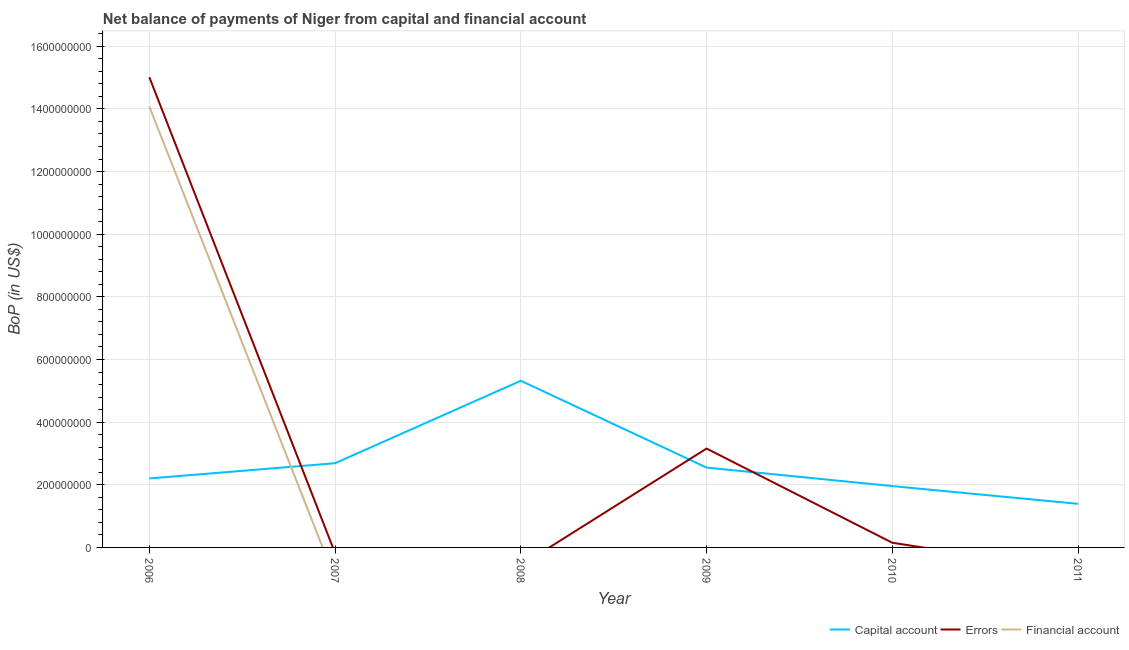How many different coloured lines are there?
Your answer should be very brief. 3. Does the line corresponding to amount of net capital account intersect with the line corresponding to amount of financial account?
Provide a short and direct response. Yes. Is the number of lines equal to the number of legend labels?
Provide a succinct answer. No. What is the amount of errors in 2006?
Your answer should be compact. 1.50e+09. Across all years, what is the maximum amount of errors?
Offer a very short reply. 1.50e+09. What is the total amount of errors in the graph?
Ensure brevity in your answer.  1.83e+09. What is the difference between the amount of net capital account in 2008 and that in 2011?
Give a very brief answer. 3.93e+08. What is the difference between the amount of errors in 2006 and the amount of financial account in 2009?
Keep it short and to the point. 1.50e+09. What is the average amount of financial account per year?
Give a very brief answer. 2.35e+08. In the year 2010, what is the difference between the amount of net capital account and amount of errors?
Keep it short and to the point. 1.81e+08. What is the ratio of the amount of errors in 2006 to that in 2009?
Keep it short and to the point. 4.76. What is the difference between the highest and the second highest amount of errors?
Make the answer very short. 1.19e+09. What is the difference between the highest and the lowest amount of net capital account?
Provide a short and direct response. 3.93e+08. In how many years, is the amount of financial account greater than the average amount of financial account taken over all years?
Make the answer very short. 1. Is the sum of the amount of net capital account in 2006 and 2011 greater than the maximum amount of errors across all years?
Make the answer very short. No. Does the amount of financial account monotonically increase over the years?
Your answer should be very brief. No. Is the amount of errors strictly greater than the amount of net capital account over the years?
Keep it short and to the point. No. How many lines are there?
Your response must be concise. 3. How many years are there in the graph?
Your answer should be very brief. 6. What is the difference between two consecutive major ticks on the Y-axis?
Offer a terse response. 2.00e+08. Does the graph contain any zero values?
Give a very brief answer. Yes. Does the graph contain grids?
Offer a very short reply. Yes. How many legend labels are there?
Offer a very short reply. 3. What is the title of the graph?
Your answer should be compact. Net balance of payments of Niger from capital and financial account. Does "Argument" appear as one of the legend labels in the graph?
Your answer should be very brief. No. What is the label or title of the X-axis?
Offer a very short reply. Year. What is the label or title of the Y-axis?
Keep it short and to the point. BoP (in US$). What is the BoP (in US$) in Capital account in 2006?
Keep it short and to the point. 2.20e+08. What is the BoP (in US$) in Errors in 2006?
Offer a very short reply. 1.50e+09. What is the BoP (in US$) of Financial account in 2006?
Provide a succinct answer. 1.41e+09. What is the BoP (in US$) in Capital account in 2007?
Your answer should be very brief. 2.69e+08. What is the BoP (in US$) in Errors in 2007?
Keep it short and to the point. 0. What is the BoP (in US$) of Capital account in 2008?
Your response must be concise. 5.32e+08. What is the BoP (in US$) in Financial account in 2008?
Offer a terse response. 0. What is the BoP (in US$) of Capital account in 2009?
Your response must be concise. 2.55e+08. What is the BoP (in US$) of Errors in 2009?
Offer a very short reply. 3.16e+08. What is the BoP (in US$) in Financial account in 2009?
Give a very brief answer. 0. What is the BoP (in US$) of Capital account in 2010?
Your answer should be very brief. 1.96e+08. What is the BoP (in US$) in Errors in 2010?
Provide a succinct answer. 1.49e+07. What is the BoP (in US$) of Financial account in 2010?
Provide a succinct answer. 0. What is the BoP (in US$) of Capital account in 2011?
Keep it short and to the point. 1.39e+08. Across all years, what is the maximum BoP (in US$) of Capital account?
Provide a succinct answer. 5.32e+08. Across all years, what is the maximum BoP (in US$) of Errors?
Make the answer very short. 1.50e+09. Across all years, what is the maximum BoP (in US$) in Financial account?
Give a very brief answer. 1.41e+09. Across all years, what is the minimum BoP (in US$) of Capital account?
Your response must be concise. 1.39e+08. Across all years, what is the minimum BoP (in US$) of Financial account?
Give a very brief answer. 0. What is the total BoP (in US$) of Capital account in the graph?
Your answer should be very brief. 1.61e+09. What is the total BoP (in US$) of Errors in the graph?
Your answer should be compact. 1.83e+09. What is the total BoP (in US$) in Financial account in the graph?
Provide a succinct answer. 1.41e+09. What is the difference between the BoP (in US$) in Capital account in 2006 and that in 2007?
Provide a short and direct response. -4.87e+07. What is the difference between the BoP (in US$) of Capital account in 2006 and that in 2008?
Provide a short and direct response. -3.12e+08. What is the difference between the BoP (in US$) in Capital account in 2006 and that in 2009?
Keep it short and to the point. -3.47e+07. What is the difference between the BoP (in US$) in Errors in 2006 and that in 2009?
Your answer should be compact. 1.19e+09. What is the difference between the BoP (in US$) of Capital account in 2006 and that in 2010?
Keep it short and to the point. 2.43e+07. What is the difference between the BoP (in US$) of Errors in 2006 and that in 2010?
Keep it short and to the point. 1.49e+09. What is the difference between the BoP (in US$) of Capital account in 2006 and that in 2011?
Provide a short and direct response. 8.10e+07. What is the difference between the BoP (in US$) of Capital account in 2007 and that in 2008?
Your response must be concise. -2.63e+08. What is the difference between the BoP (in US$) of Capital account in 2007 and that in 2009?
Give a very brief answer. 1.39e+07. What is the difference between the BoP (in US$) in Capital account in 2007 and that in 2010?
Keep it short and to the point. 7.30e+07. What is the difference between the BoP (in US$) of Capital account in 2007 and that in 2011?
Provide a succinct answer. 1.30e+08. What is the difference between the BoP (in US$) in Capital account in 2008 and that in 2009?
Your response must be concise. 2.77e+08. What is the difference between the BoP (in US$) in Capital account in 2008 and that in 2010?
Provide a succinct answer. 3.36e+08. What is the difference between the BoP (in US$) in Capital account in 2008 and that in 2011?
Your response must be concise. 3.93e+08. What is the difference between the BoP (in US$) of Capital account in 2009 and that in 2010?
Ensure brevity in your answer.  5.91e+07. What is the difference between the BoP (in US$) of Errors in 2009 and that in 2010?
Your answer should be compact. 3.01e+08. What is the difference between the BoP (in US$) in Capital account in 2009 and that in 2011?
Keep it short and to the point. 1.16e+08. What is the difference between the BoP (in US$) of Capital account in 2010 and that in 2011?
Make the answer very short. 5.66e+07. What is the difference between the BoP (in US$) in Capital account in 2006 and the BoP (in US$) in Errors in 2009?
Make the answer very short. -9.55e+07. What is the difference between the BoP (in US$) in Capital account in 2006 and the BoP (in US$) in Errors in 2010?
Your response must be concise. 2.05e+08. What is the difference between the BoP (in US$) in Capital account in 2007 and the BoP (in US$) in Errors in 2009?
Your answer should be compact. -4.68e+07. What is the difference between the BoP (in US$) in Capital account in 2007 and the BoP (in US$) in Errors in 2010?
Provide a short and direct response. 2.54e+08. What is the difference between the BoP (in US$) of Capital account in 2008 and the BoP (in US$) of Errors in 2009?
Ensure brevity in your answer.  2.16e+08. What is the difference between the BoP (in US$) in Capital account in 2008 and the BoP (in US$) in Errors in 2010?
Your answer should be very brief. 5.17e+08. What is the difference between the BoP (in US$) of Capital account in 2009 and the BoP (in US$) of Errors in 2010?
Provide a succinct answer. 2.40e+08. What is the average BoP (in US$) of Capital account per year?
Your answer should be compact. 2.69e+08. What is the average BoP (in US$) of Errors per year?
Your answer should be very brief. 3.05e+08. What is the average BoP (in US$) of Financial account per year?
Ensure brevity in your answer.  2.35e+08. In the year 2006, what is the difference between the BoP (in US$) in Capital account and BoP (in US$) in Errors?
Your answer should be very brief. -1.28e+09. In the year 2006, what is the difference between the BoP (in US$) in Capital account and BoP (in US$) in Financial account?
Your answer should be compact. -1.19e+09. In the year 2006, what is the difference between the BoP (in US$) of Errors and BoP (in US$) of Financial account?
Your answer should be compact. 9.36e+07. In the year 2009, what is the difference between the BoP (in US$) of Capital account and BoP (in US$) of Errors?
Your answer should be very brief. -6.08e+07. In the year 2010, what is the difference between the BoP (in US$) in Capital account and BoP (in US$) in Errors?
Offer a very short reply. 1.81e+08. What is the ratio of the BoP (in US$) in Capital account in 2006 to that in 2007?
Offer a very short reply. 0.82. What is the ratio of the BoP (in US$) in Capital account in 2006 to that in 2008?
Your answer should be very brief. 0.41. What is the ratio of the BoP (in US$) of Capital account in 2006 to that in 2009?
Keep it short and to the point. 0.86. What is the ratio of the BoP (in US$) in Errors in 2006 to that in 2009?
Provide a succinct answer. 4.76. What is the ratio of the BoP (in US$) in Capital account in 2006 to that in 2010?
Give a very brief answer. 1.12. What is the ratio of the BoP (in US$) of Errors in 2006 to that in 2010?
Your answer should be very brief. 100.8. What is the ratio of the BoP (in US$) in Capital account in 2006 to that in 2011?
Keep it short and to the point. 1.58. What is the ratio of the BoP (in US$) of Capital account in 2007 to that in 2008?
Provide a short and direct response. 0.51. What is the ratio of the BoP (in US$) in Capital account in 2007 to that in 2009?
Keep it short and to the point. 1.05. What is the ratio of the BoP (in US$) in Capital account in 2007 to that in 2010?
Provide a short and direct response. 1.37. What is the ratio of the BoP (in US$) in Capital account in 2007 to that in 2011?
Keep it short and to the point. 1.93. What is the ratio of the BoP (in US$) in Capital account in 2008 to that in 2009?
Provide a succinct answer. 2.09. What is the ratio of the BoP (in US$) in Capital account in 2008 to that in 2010?
Your answer should be very brief. 2.72. What is the ratio of the BoP (in US$) in Capital account in 2008 to that in 2011?
Your answer should be very brief. 3.82. What is the ratio of the BoP (in US$) of Capital account in 2009 to that in 2010?
Give a very brief answer. 1.3. What is the ratio of the BoP (in US$) in Errors in 2009 to that in 2010?
Your answer should be very brief. 21.2. What is the ratio of the BoP (in US$) of Capital account in 2009 to that in 2011?
Offer a terse response. 1.83. What is the ratio of the BoP (in US$) of Capital account in 2010 to that in 2011?
Keep it short and to the point. 1.41. What is the difference between the highest and the second highest BoP (in US$) in Capital account?
Offer a terse response. 2.63e+08. What is the difference between the highest and the second highest BoP (in US$) of Errors?
Make the answer very short. 1.19e+09. What is the difference between the highest and the lowest BoP (in US$) in Capital account?
Keep it short and to the point. 3.93e+08. What is the difference between the highest and the lowest BoP (in US$) of Errors?
Offer a terse response. 1.50e+09. What is the difference between the highest and the lowest BoP (in US$) in Financial account?
Give a very brief answer. 1.41e+09. 